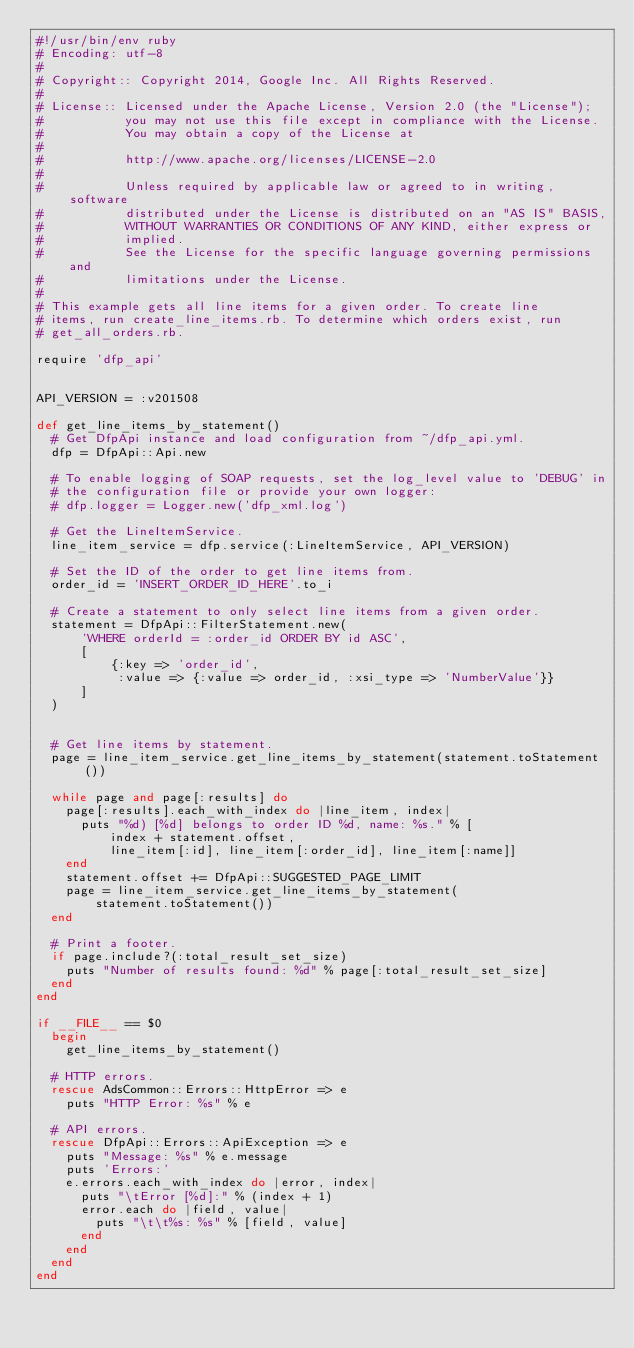Convert code to text. <code><loc_0><loc_0><loc_500><loc_500><_Ruby_>#!/usr/bin/env ruby
# Encoding: utf-8
#
# Copyright:: Copyright 2014, Google Inc. All Rights Reserved.
#
# License:: Licensed under the Apache License, Version 2.0 (the "License");
#           you may not use this file except in compliance with the License.
#           You may obtain a copy of the License at
#
#           http://www.apache.org/licenses/LICENSE-2.0
#
#           Unless required by applicable law or agreed to in writing, software
#           distributed under the License is distributed on an "AS IS" BASIS,
#           WITHOUT WARRANTIES OR CONDITIONS OF ANY KIND, either express or
#           implied.
#           See the License for the specific language governing permissions and
#           limitations under the License.
#
# This example gets all line items for a given order. To create line
# items, run create_line_items.rb. To determine which orders exist, run
# get_all_orders.rb.

require 'dfp_api'


API_VERSION = :v201508

def get_line_items_by_statement()
  # Get DfpApi instance and load configuration from ~/dfp_api.yml.
  dfp = DfpApi::Api.new

  # To enable logging of SOAP requests, set the log_level value to 'DEBUG' in
  # the configuration file or provide your own logger:
  # dfp.logger = Logger.new('dfp_xml.log')

  # Get the LineItemService.
  line_item_service = dfp.service(:LineItemService, API_VERSION)

  # Set the ID of the order to get line items from.
  order_id = 'INSERT_ORDER_ID_HERE'.to_i

  # Create a statement to only select line items from a given order.
  statement = DfpApi::FilterStatement.new(
      'WHERE orderId = :order_id ORDER BY id ASC',
      [
          {:key => 'order_id',
           :value => {:value => order_id, :xsi_type => 'NumberValue'}}
      ]
  )


  # Get line items by statement.
  page = line_item_service.get_line_items_by_statement(statement.toStatement())

  while page and page[:results] do
    page[:results].each_with_index do |line_item, index|
      puts "%d) [%d] belongs to order ID %d, name: %s." % [
          index + statement.offset,
          line_item[:id], line_item[:order_id], line_item[:name]]
    end
    statement.offset += DfpApi::SUGGESTED_PAGE_LIMIT
    page = line_item_service.get_line_items_by_statement(
        statement.toStatement())
  end

  # Print a footer.
  if page.include?(:total_result_set_size)
    puts "Number of results found: %d" % page[:total_result_set_size]
  end
end

if __FILE__ == $0
  begin
    get_line_items_by_statement()

  # HTTP errors.
  rescue AdsCommon::Errors::HttpError => e
    puts "HTTP Error: %s" % e

  # API errors.
  rescue DfpApi::Errors::ApiException => e
    puts "Message: %s" % e.message
    puts 'Errors:'
    e.errors.each_with_index do |error, index|
      puts "\tError [%d]:" % (index + 1)
      error.each do |field, value|
        puts "\t\t%s: %s" % [field, value]
      end
    end
  end
end
</code> 